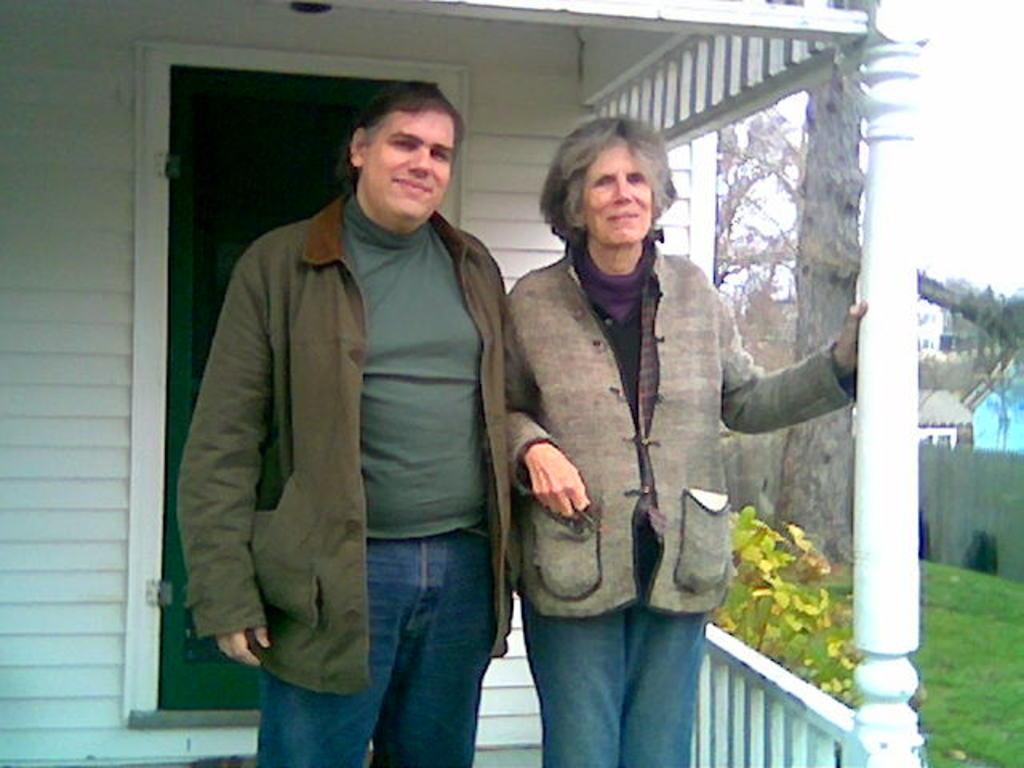In one or two sentences, can you explain what this image depicts? In this picture we can see two people and they are smiling and in the background we can see buildings, trees, grass, sky. 